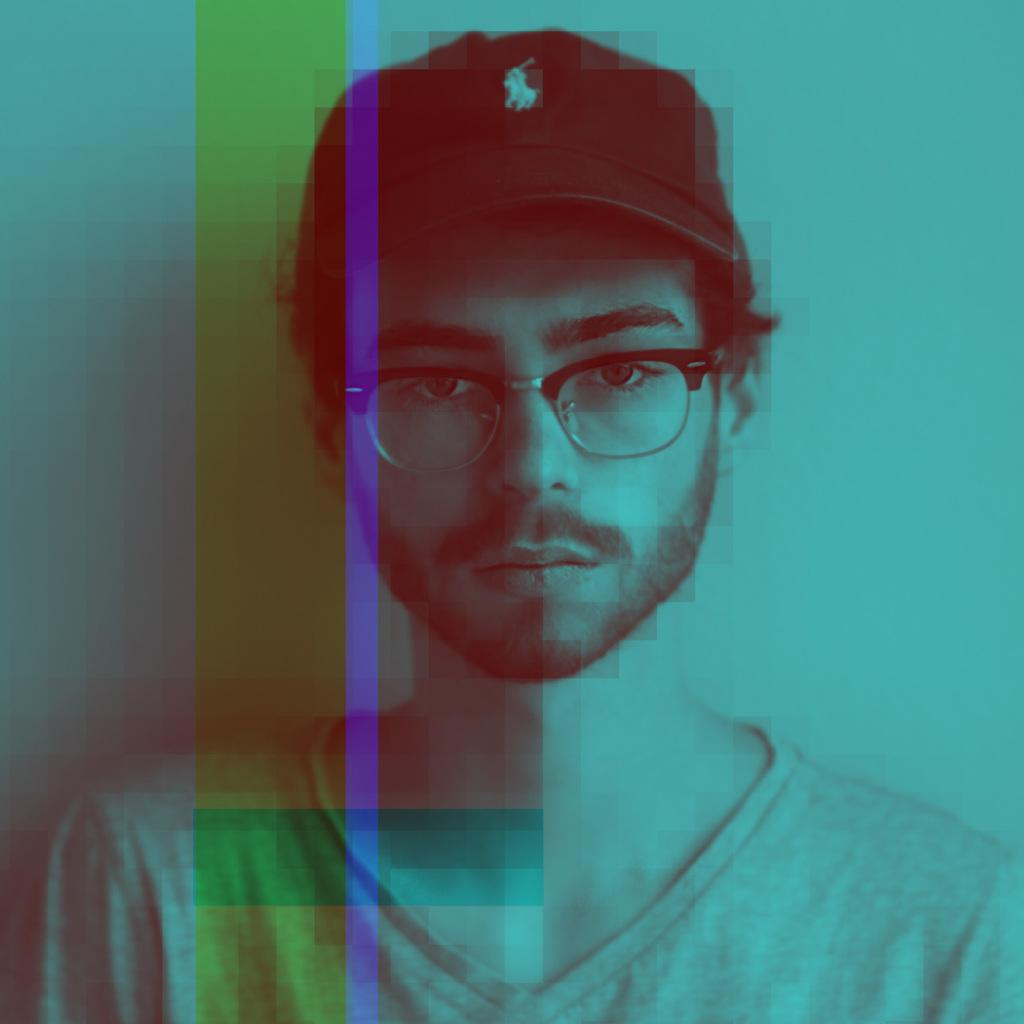What is the main subject in the foreground of the picture? There is a person in the foreground of the picture. What accessories is the person wearing? The person is wearing a cap and spectacles. What can be seen in the background of the picture? There is a wall in the background of the picture. Can you describe the nature of the image? The image is an edited picture. What type of collar can be seen on the actor in the image? There is no actor present in the image, and therefore no collar can be observed. What type of prose is being recited by the person in the image? There is no indication in the image that the person is reciting any prose. 